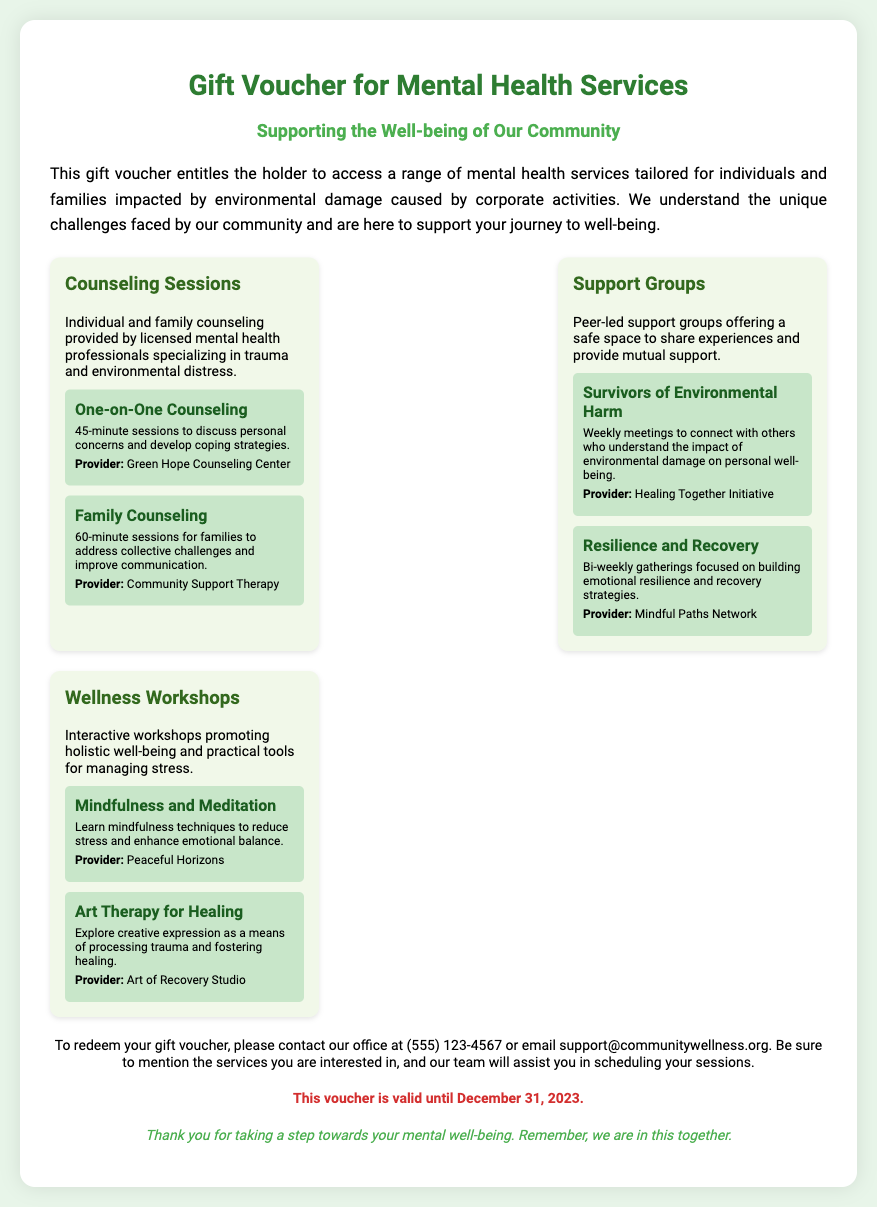What is the title of the document? The title of the document is specified in the header section, which is "Gift Voucher for Mental Health Services."
Answer: Gift Voucher for Mental Health Services What types of services are included in the voucher? The voucher includes Counseling Sessions, Support Groups, and Wellness Workshops as specified in the services section.
Answer: Counseling Sessions, Support Groups, and Wellness Workshops Who provides the One-on-One Counseling? The provider for One-on-One Counseling is mentioned under the counseling section of the services, which is "Green Hope Counseling Center."
Answer: Green Hope Counseling Center How long is a Family Counseling session? The duration of the Family Counseling session is provided in the service options section where it states it lasts for 60 minutes.
Answer: 60 minutes When is the voucher valid until? The validity of the voucher is specifically stated in the document as December 31, 2023.
Answer: December 31, 2023 What is the purpose of the Support Groups? The purpose of the Support Groups is stated as providing a safe space to share experiences and provide mutual support.
Answer: Safe space to share experiences and provide mutual support How frequently do the Survivors of Environmental Harm support groups meet? The meeting frequency for the Survivors of Environmental Harm support group is mentioned as weekly.
Answer: Weekly What method of contact should be used to redeem the voucher? The method of contact specified for redeeming the voucher is by phone or email, with the phone number being (555) 123-4567.
Answer: Phone or email What workshop focuses on mindfulness techniques? The workshop that focuses on mindfulness techniques is listed as "Mindfulness and Meditation."
Answer: Mindfulness and Meditation 